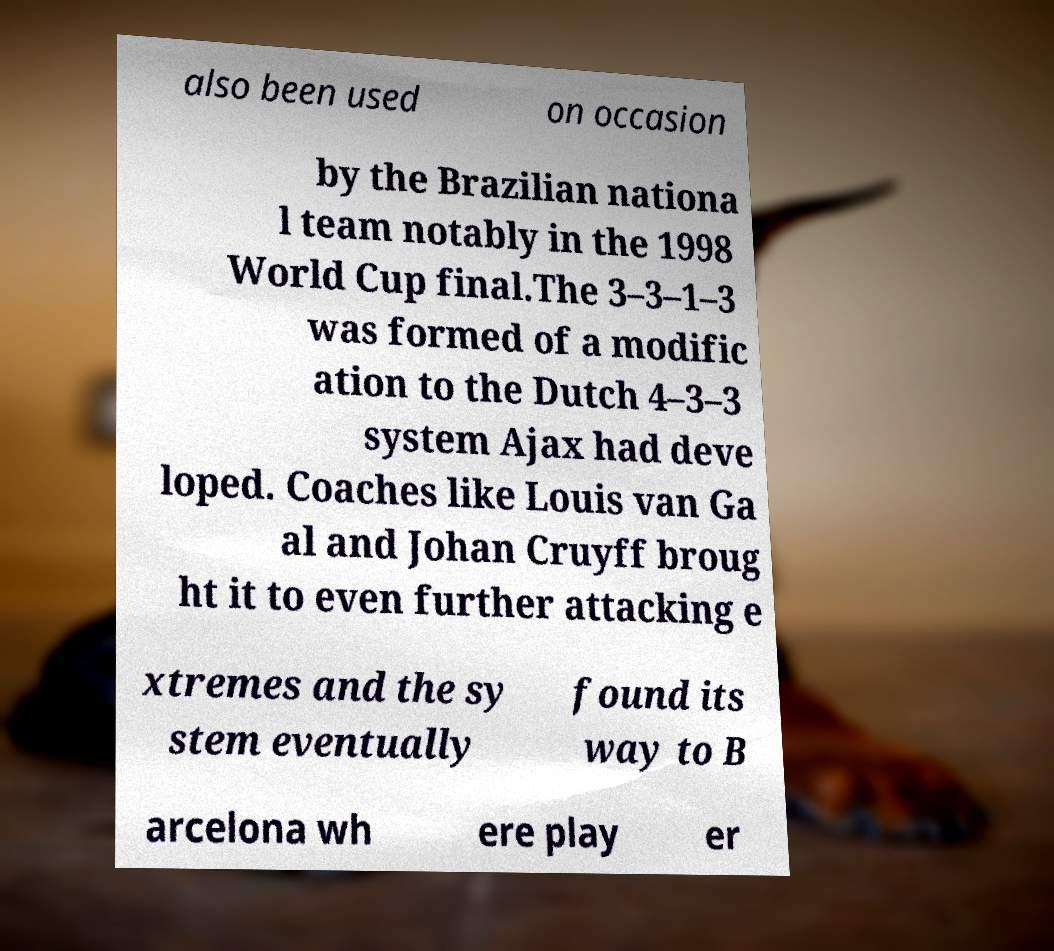Please identify and transcribe the text found in this image. also been used on occasion by the Brazilian nationa l team notably in the 1998 World Cup final.The 3–3–1–3 was formed of a modific ation to the Dutch 4–3–3 system Ajax had deve loped. Coaches like Louis van Ga al and Johan Cruyff broug ht it to even further attacking e xtremes and the sy stem eventually found its way to B arcelona wh ere play er 